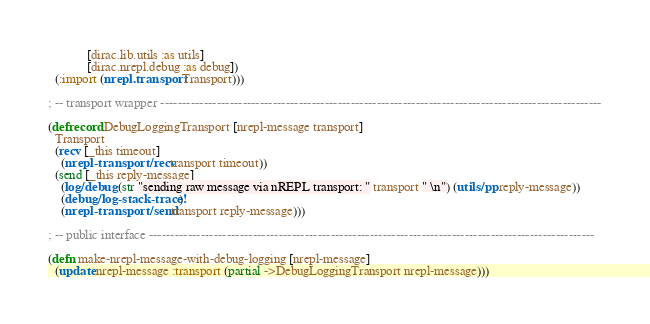Convert code to text. <code><loc_0><loc_0><loc_500><loc_500><_Clojure_>            [dirac.lib.utils :as utils]
            [dirac.nrepl.debug :as debug])
  (:import (nrepl.transport Transport)))

; -- transport wrapper ------------------------------------------------------------------------------------------------------

(defrecord DebugLoggingTransport [nrepl-message transport]
  Transport
  (recv [_this timeout]
    (nrepl-transport/recv transport timeout))
  (send [_this reply-message]
    (log/debug (str "sending raw message via nREPL transport: " transport " \n") (utils/pp reply-message))
    (debug/log-stack-trace!)
    (nrepl-transport/send transport reply-message)))

; -- public interface -------------------------------------------------------------------------------------------------------

(defn make-nrepl-message-with-debug-logging [nrepl-message]
  (update nrepl-message :transport (partial ->DebugLoggingTransport nrepl-message)))
</code> 